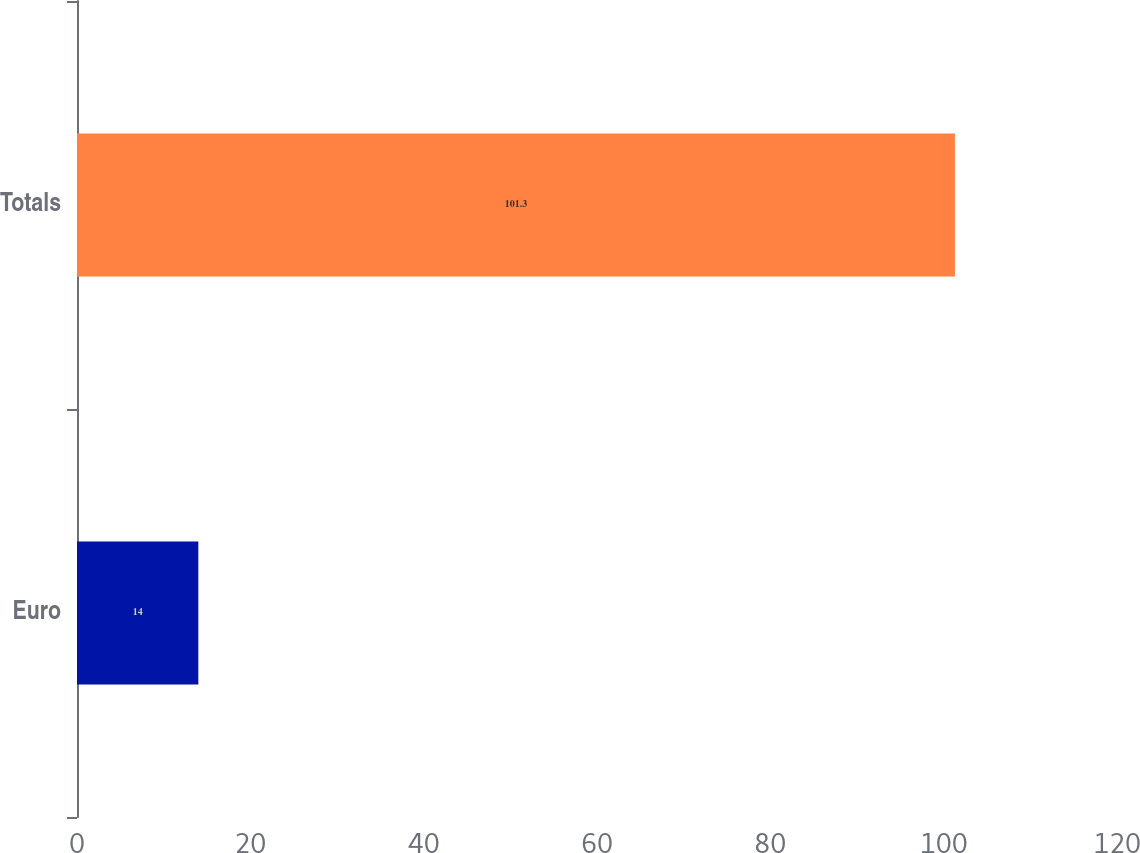Convert chart to OTSL. <chart><loc_0><loc_0><loc_500><loc_500><bar_chart><fcel>Euro<fcel>Totals<nl><fcel>14<fcel>101.3<nl></chart> 